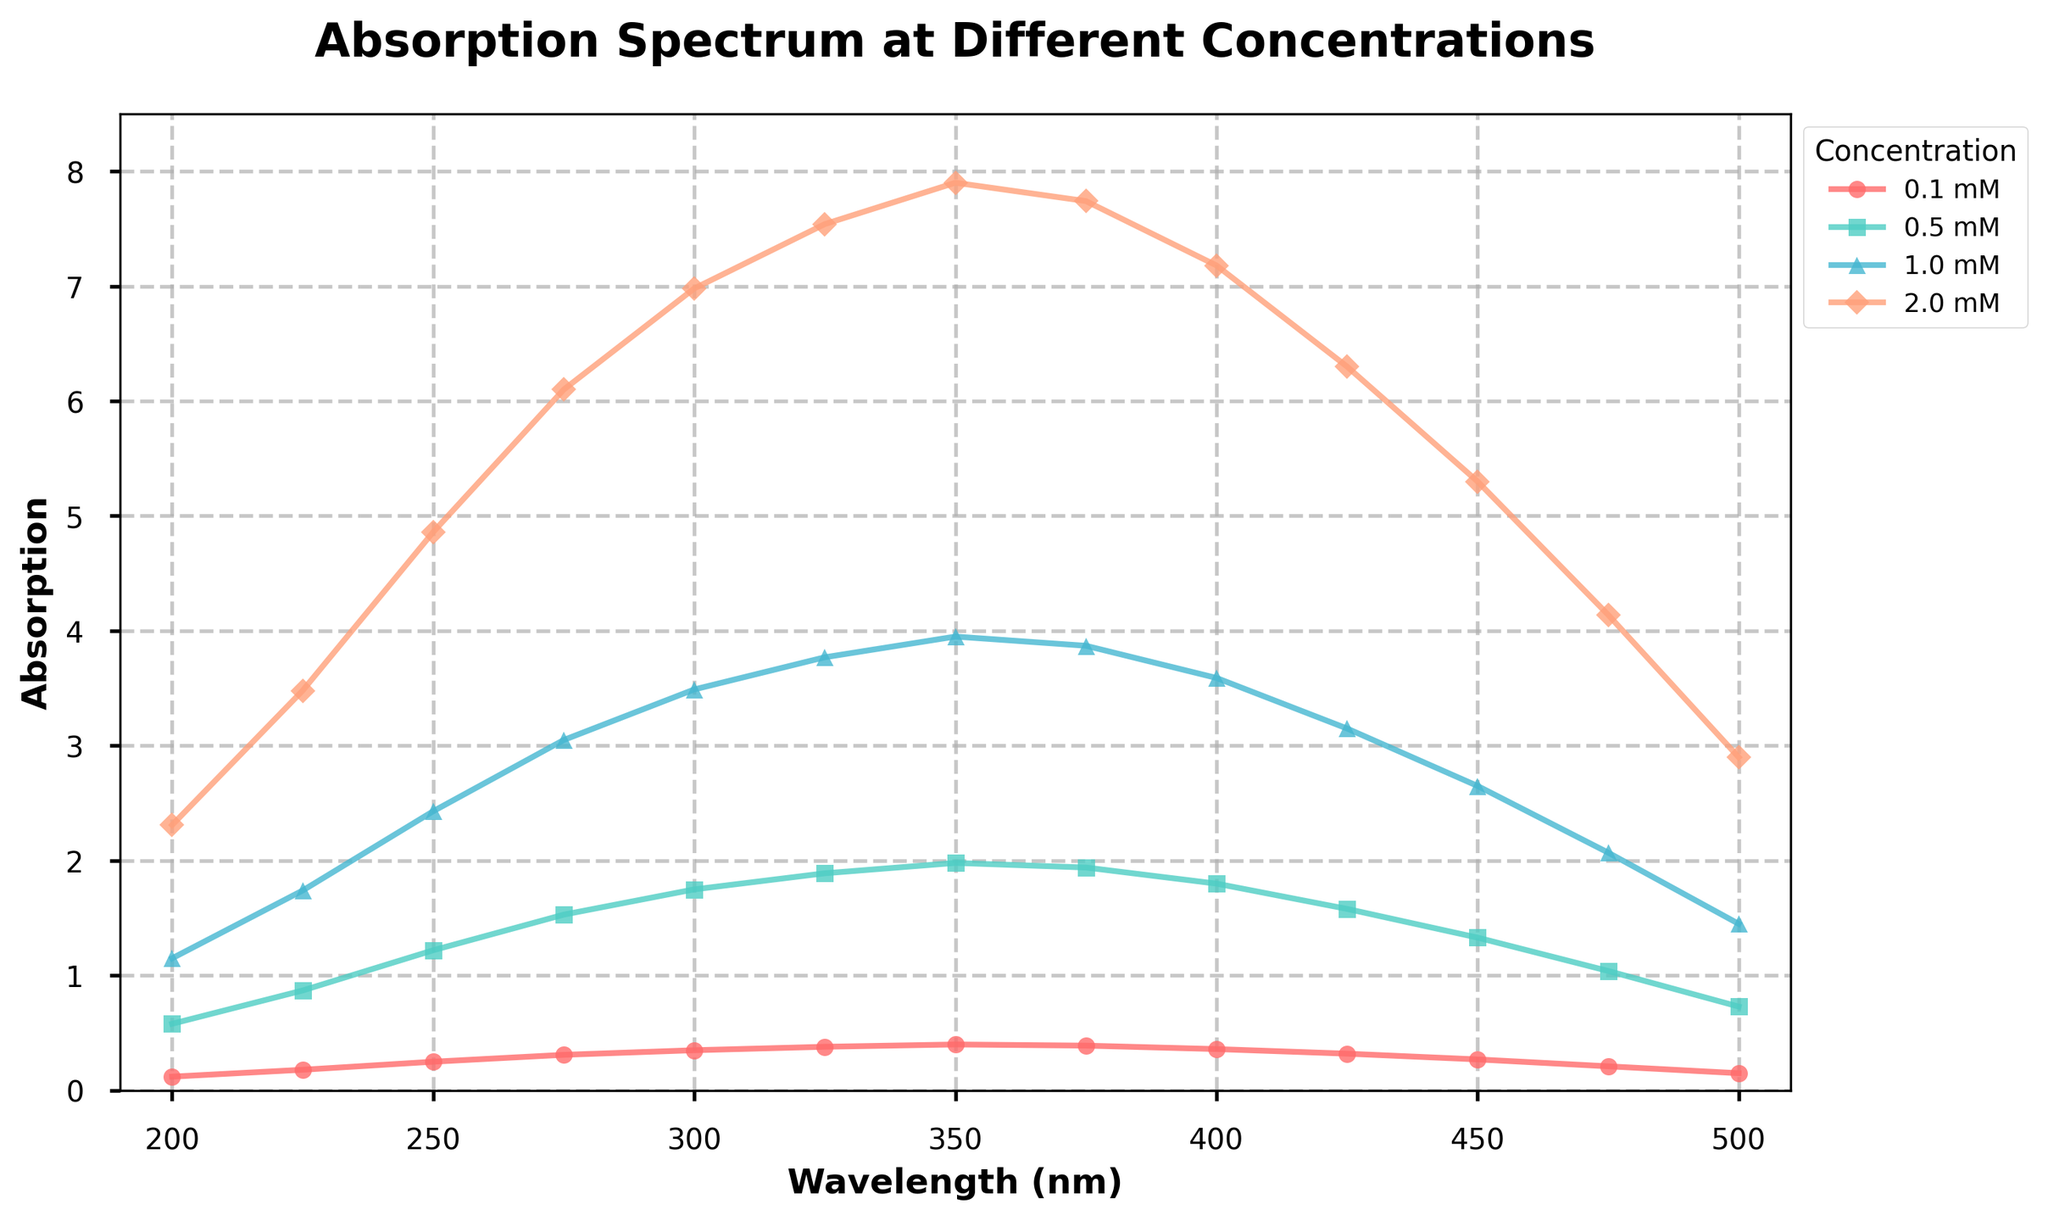What's the absorption value at 300 nm for 0.5 mM concentration? Look at the curve labeled "0.5 mM" and find the absorption value at the wavelength of 300 nm. It is given as 1.75.
Answer: 1.75 At which wavelength does the 1.0 mM concentration show the highest absorption? Identify the peak point on the "1.0 mM" curve. The highest absorption is at 350 nm with a value of 3.95.
Answer: 350 nm Compare the absorption at 475 nm for 0.1 mM and 2.0 mM concentrations. Which one is higher and by how much? Find the absorption values at 475 nm for both concentrations: 0.1 mM = 0.21 and 2.0 mM = 4.14. Subtract the smaller value from the larger value: 4.14 - 0.21 = 3.93.
Answer: 2.0 mM by 3.93 What is the average absorption value for the 0.1 mM concentration across all wavelengths? Sum the absorption values for 0.1 mM concentration: 0.12 + 0.18 + 0.25 + 0.31 + 0.35 + 0.38 + 0.40 + 0.39 + 0.36 + 0.32 + 0.27 + 0.21 + 0.15 = 3.69. Divide by the number of data points (13): 3.69 / 13 ≈ 0.2846.
Answer: 0.2846 Is the absorption at 425 nm for the 0.5 mM concentration greater than or less than absorption at 275 nm for 0.1 mM concentration? Compare the values: At 425 nm, 0.5 mM has an absorption of 1.58. At 275 nm, 0.1 mM has an absorption of 0.31. Since 1.58 > 0.31.
Answer: Greater What color represents the 2.0 mM concentration in the plot? Identify the color of the curve labeled "2.0 mM," which is orange.
Answer: Orange Calculate the difference in absorption for the 1.0 mM concentration between wavelengths 400 nm and 300 nm. Absorption at 400 nm for 1.0 mM = 3.59. Absorption at 300 nm for 1.0 mM = 3.49. Find the difference: 3.59 - 3.49 = 0.1.
Answer: 0.1 Which concentration shows the least change in absorption from 375 nm to 450 nm? Determine the absorption values at 375 nm and 450 nm for each concentration and calculate the change:
- 0.1 mM: 0.39 - 0.27 = 0.12
- 0.5 mM: 1.94 - 1.33 = 0.61
- 1.0 mM: 3.87 - 2.65 = 1.22
- 2.0 mM: 7.74 - 5.30 = 2.44
The least change is for the 0.1 mM concentration.
Answer: 0.1 mM What is the absorption difference between 0.5 mM and 1.0 mM concentrations at 250 nm? Absorption at 250 nm for 0.5 mM = 1.22 and for 1.0 mM = 2.43. Find the difference: 2.43 - 1.22 = 1.21.
Answer: 1.21 